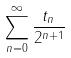Convert formula to latex. <formula><loc_0><loc_0><loc_500><loc_500>\sum _ { n = 0 } ^ { \infty } \frac { t _ { n } } { 2 ^ { n + 1 } }</formula> 